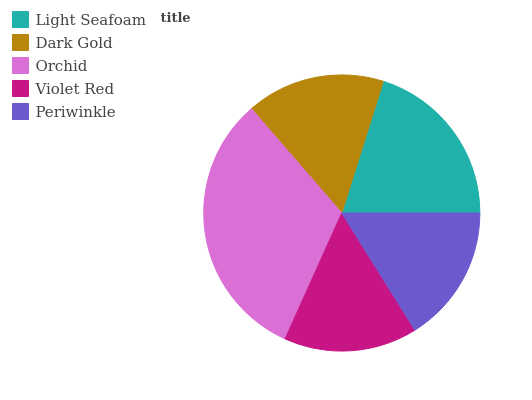Is Violet Red the minimum?
Answer yes or no. Yes. Is Orchid the maximum?
Answer yes or no. Yes. Is Dark Gold the minimum?
Answer yes or no. No. Is Dark Gold the maximum?
Answer yes or no. No. Is Light Seafoam greater than Dark Gold?
Answer yes or no. Yes. Is Dark Gold less than Light Seafoam?
Answer yes or no. Yes. Is Dark Gold greater than Light Seafoam?
Answer yes or no. No. Is Light Seafoam less than Dark Gold?
Answer yes or no. No. Is Dark Gold the high median?
Answer yes or no. Yes. Is Dark Gold the low median?
Answer yes or no. Yes. Is Periwinkle the high median?
Answer yes or no. No. Is Periwinkle the low median?
Answer yes or no. No. 